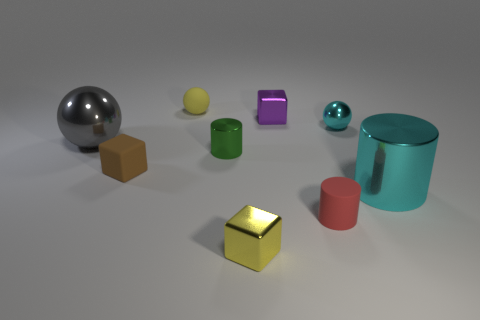Are there any small metallic cylinders that have the same color as the big metallic sphere?
Make the answer very short. No. How many metallic things are cyan cylinders or tiny green blocks?
Keep it short and to the point. 1. Is there a yellow sphere that has the same material as the tiny purple object?
Your response must be concise. No. What number of things are behind the large gray thing and right of the green object?
Provide a succinct answer. 2. Are there fewer tiny green cylinders that are left of the green metallic cylinder than green objects that are left of the cyan metal sphere?
Provide a succinct answer. Yes. Is the tiny purple metal object the same shape as the small yellow rubber thing?
Your response must be concise. No. How many other objects are there of the same size as the purple metallic object?
Ensure brevity in your answer.  6. How many objects are metal cylinders on the right side of the rubber cylinder or tiny objects to the left of the tiny purple metallic cube?
Ensure brevity in your answer.  5. What number of tiny yellow things are the same shape as the brown thing?
Your answer should be very brief. 1. There is a small object that is in front of the large cyan metallic object and left of the tiny red cylinder; what material is it made of?
Make the answer very short. Metal. 